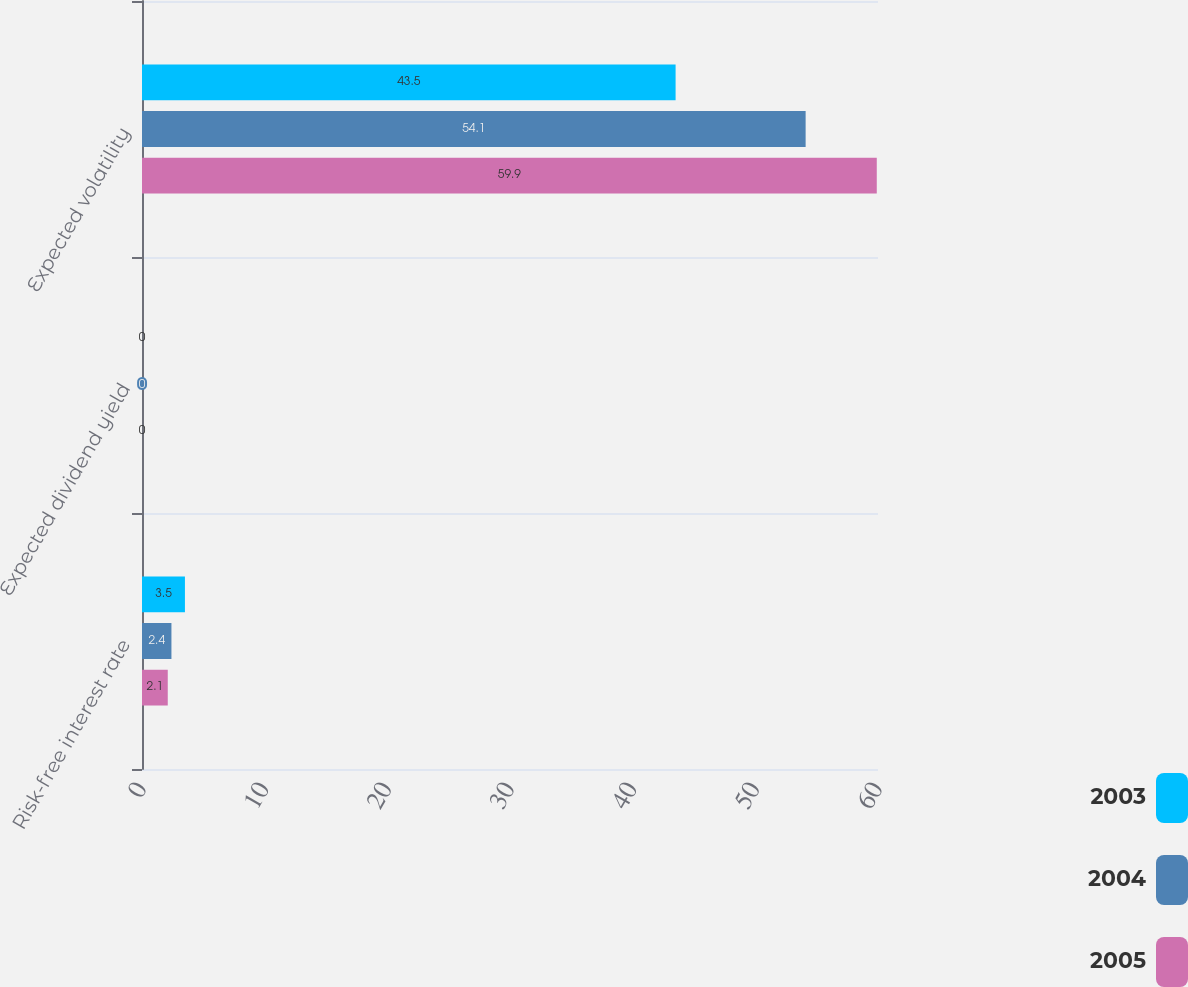<chart> <loc_0><loc_0><loc_500><loc_500><stacked_bar_chart><ecel><fcel>Risk-free interest rate<fcel>Expected dividend yield<fcel>Expected volatility<nl><fcel>2003<fcel>3.5<fcel>0<fcel>43.5<nl><fcel>2004<fcel>2.4<fcel>0<fcel>54.1<nl><fcel>2005<fcel>2.1<fcel>0<fcel>59.9<nl></chart> 